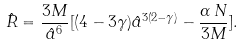Convert formula to latex. <formula><loc_0><loc_0><loc_500><loc_500>\hat { R } = \frac { 3 M } { \hat { a } ^ { 6 } } [ ( 4 - 3 \gamma ) \hat { a } ^ { 3 ( 2 - \gamma ) } - \frac { \alpha \, N } { 3 M } ] .</formula> 